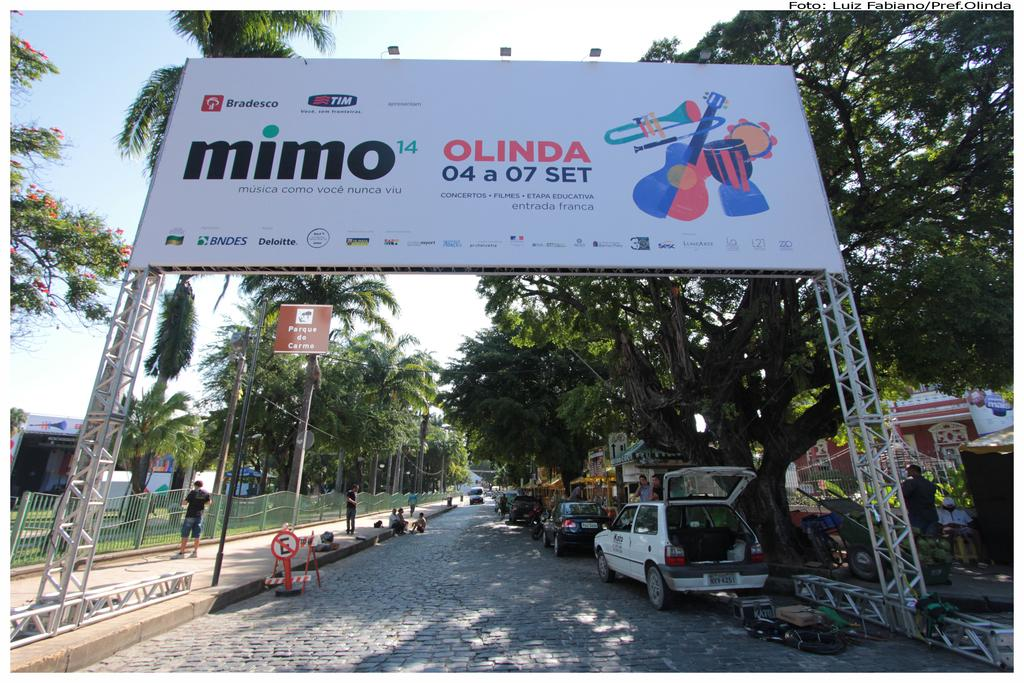What is the main feature in the image? There is a hoarding in the image. What can be seen on the road at the bottom of the image? Cars are visible on the road at the bottom of the image. Are there any people present in the image? Yes, there are people in the image. What can be seen in the background of the image? There are trees, a fence, a shed, a trolley, and the sky visible in the background of the image. How many cats are sitting on the trolley in the image? There are no cats present in the image; only a trolley can be seen in the background. What time of day is it in the image, based on the thrill of the people? The image does not provide information about the time of day or the thrill of the people, so it cannot be determined from the image. 